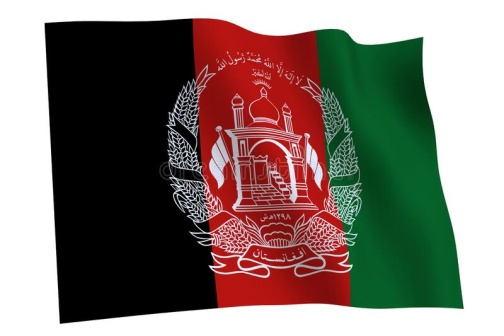Describe the following image. The image presents the flag of Afghanistan, fluttering in the wind, depicted from a three-dimensional perspective. The flag is divided into three vertical stripes, each of a different color: black on the hoist side, red in the middle, and green on the fly side. 

At the center of the flag, there's a white emblem, a significant symbol of the country. This emblem features a mosque with its mihrab facing Mecca and a pulpit in the prayer hall, signifying the Islamic faith of the nation. Flanking the mosque are two sheaves of wheat, representing the agricultural heritage of Afghanistan. 

Surrounding the emblem is an inscription in Arabic text, which reads "لا إله إلا الله محمد رسول الله", translating to "There is no god but Allah, Muhammad is the messenger of Allah". This phrase is a declaration of faith, known as the Shahada, a fundamental tenet of Islam. 

The flag's design, colors, and emblem, along with the Arabic inscription, collectively represent the rich history, culture, and religious identity of Afghanistan. 